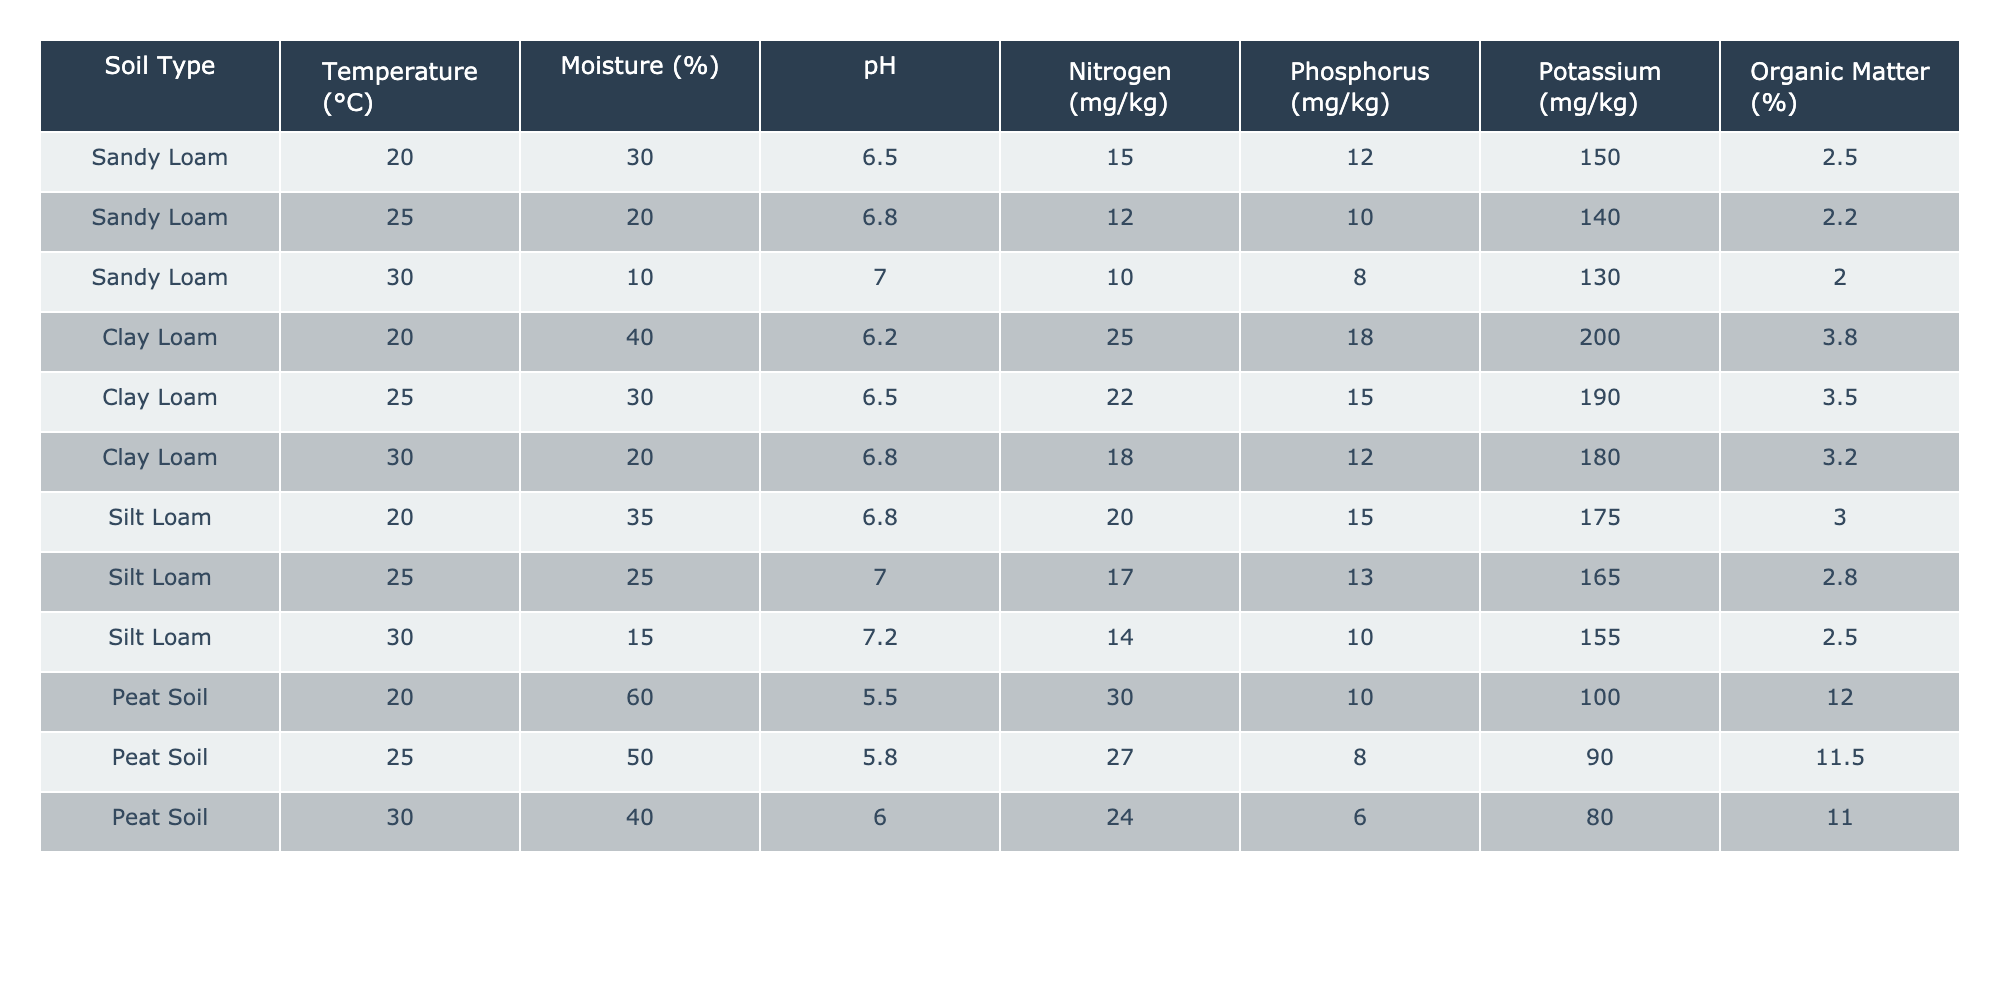What is the nitrogen concentration in Peat Soil at 30°C? According to the table, the nitrogen concentration for Peat Soil at 30°C is listed in the column under Nitrogen for that specific row. The value is 24 mg/kg.
Answer: 24 mg/kg What soil type has the highest potassium concentration? By reviewing the Potassium column across all soil types, the highest value is found in the Sandy Loam category at 150 mg/kg.
Answer: Sandy Loam What is the average pH for Clay Loam across all temperatures? The pH values for Clay Loam are 6.2, 6.5, and 6.8. To find the average, sum these values (6.2 + 6.5 + 6.8 = 19.5) and divide by the number of values (19.5 / 3 = 6.5).
Answer: 6.5 Is the organic matter content in Silt Loam lower than in Sandy Loam at 25°C? For Silt Loam at 25°C, the organic matter is 2.8%; for Sandy Loam at 25°C, it is 2.2%. Since 2.8% is greater than 2.2%, the statement is false.
Answer: No What is the difference in phosphorus concentration between Clay Loam and Peat Soil at 20°C? The phosphorus concentration for Clay Loam at 20°C is 18 mg/kg, while for Peat Soil at the same temperature it is 10 mg/kg. The difference is calculated as 18 - 10 = 8 mg/kg.
Answer: 8 mg/kg Does the nitrogen concentration in Silt Loam decrease as temperature increases from 20°C to 30°C? The nitrogen concentrations for Silt Loam at the respective temperatures are 20 mg/kg (at 20°C), 17 mg/kg (at 25°C), and 14 mg/kg (at 30°C). Since these values are steadily decreasing, the statement is true.
Answer: Yes Which soil type has the highest overall organic matter concentration? The organic matter percentages in the table are 2.5% for Sandy Loam, 3.8% for Clay Loam, 3.0% for Silt Loam, and 12.0% for Peat Soil. Peat Soil has the highest value of 12.0%.
Answer: Peat Soil What is the median nitrogen concentration for all soil types at 25°C? The nitrogen concentrations at 25°C are 12 mg/kg (Sandy Loam), 22 mg/kg (Clay Loam), 17 mg/kg (Silt Loam), and 27 mg/kg (Peat Soil). Arranging these values: 12, 17, 22, 27. The median between 17 and 22 is (17 + 22)/2 = 19.5 mg/kg.
Answer: 19.5 mg/kg If the temperature is set to increase and the moisture decreases, is it likely for the potassium concentration to increase for Sandy Loam? The data shows a trend where increasing temperature and decreasing moisture corresponds to a drop in potassium concentrations (150 mg/kg to 140 mg/kg to 130 mg/kg). This implies that potassium concentration is likely to decrease under these changes.
Answer: No 